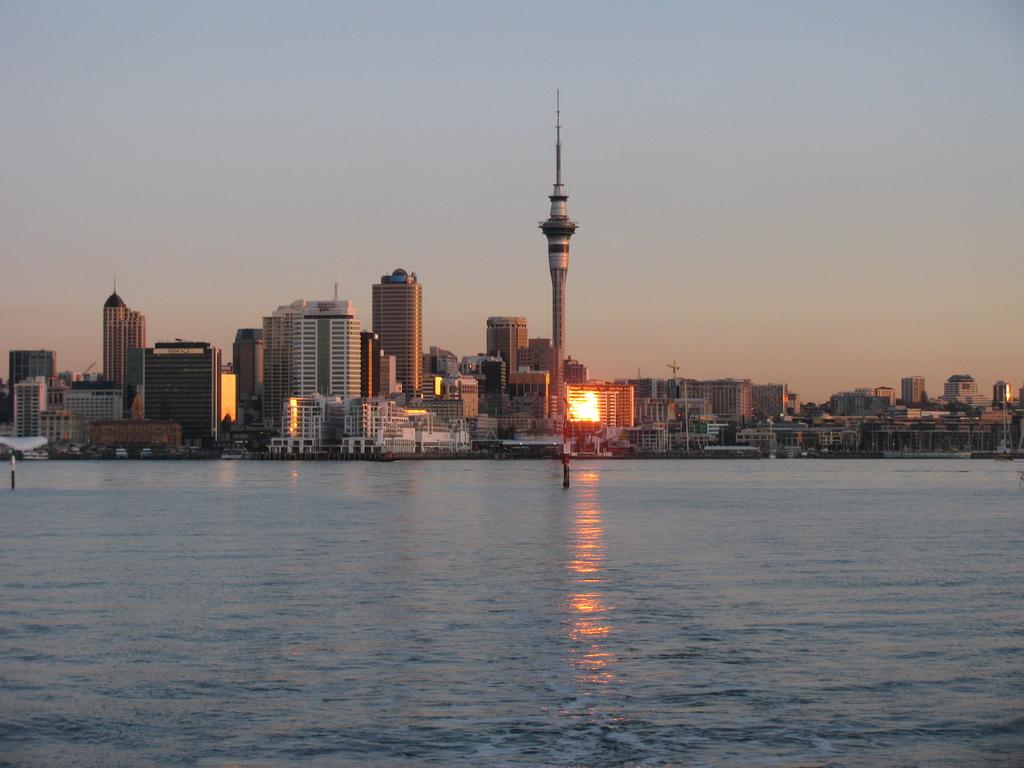What is visible in the image? Water is visible in the image. What can be seen in the background of the image? There is light, multiple buildings, and the sky visible in the background of the image. How many locks are present on the boundary of the water in the image? There are no locks or boundaries mentioned in the image, as it only contains water, light, buildings, and the sky. 